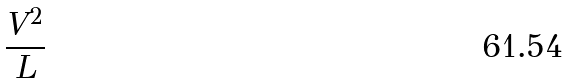<formula> <loc_0><loc_0><loc_500><loc_500>\frac { V ^ { 2 } } { L }</formula> 